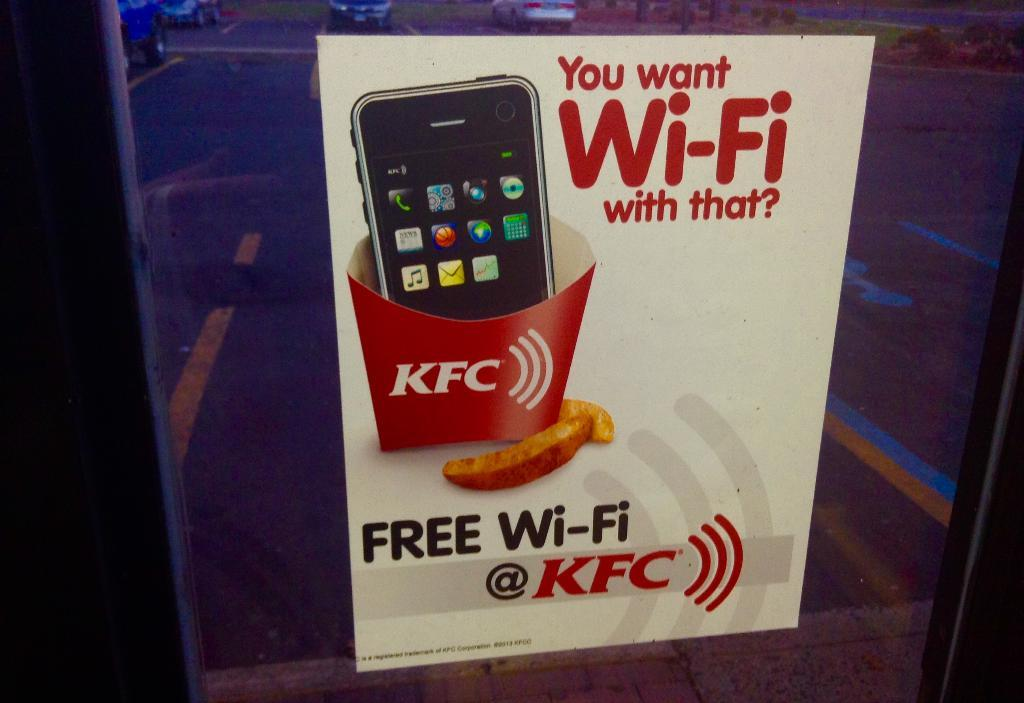<image>
Summarize the visual content of the image. A sign advertising free Wi-Fi at KFC restaurants 